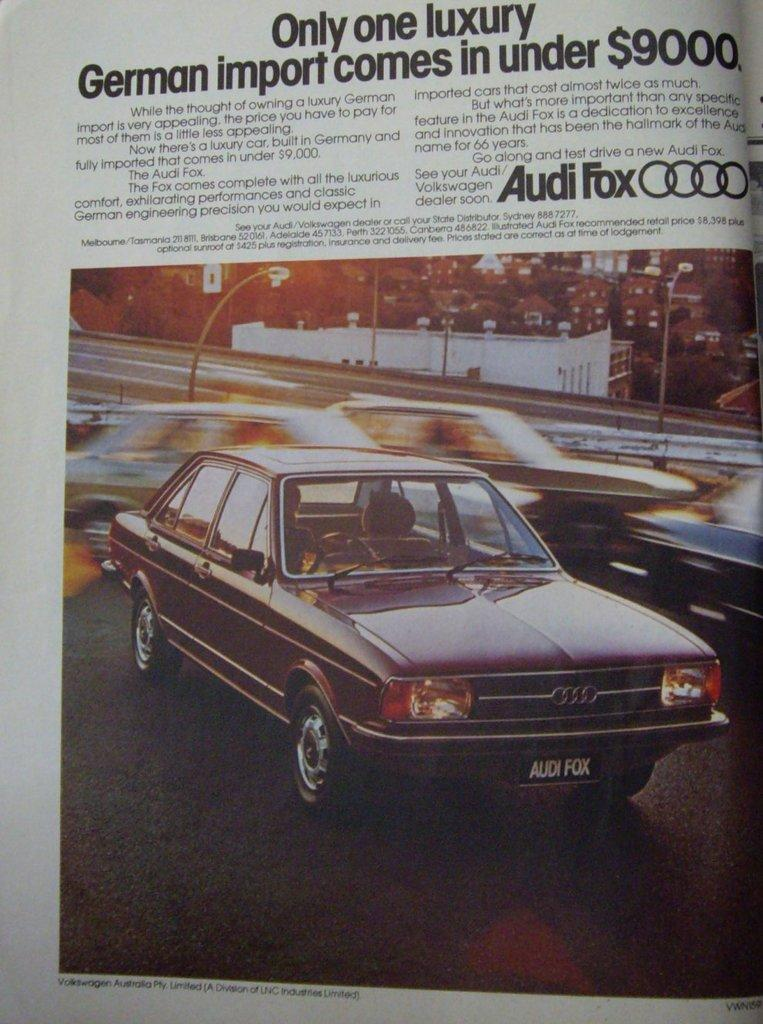What is featured on the poster in the image? The poster contains images of cars. Are there any other objects or structures visible in the image? Yes, there are lights on poles and buildings visible in the image. Is there a party happening in the image, and if so, where is the hot ball located? There is no party or hot ball present in the image. The image features a poster with images of cars, lights on poles, and buildings. 